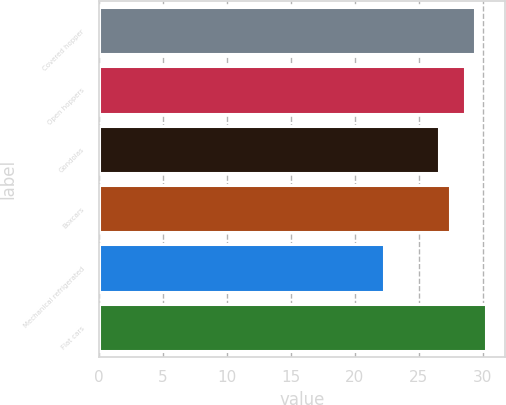Convert chart to OTSL. <chart><loc_0><loc_0><loc_500><loc_500><bar_chart><fcel>Covered hopper<fcel>Open hoppers<fcel>Gondolas<fcel>Boxcars<fcel>Mechanical refrigerated<fcel>Flat cars<nl><fcel>29.39<fcel>28.6<fcel>26.6<fcel>27.39<fcel>22.3<fcel>30.2<nl></chart> 